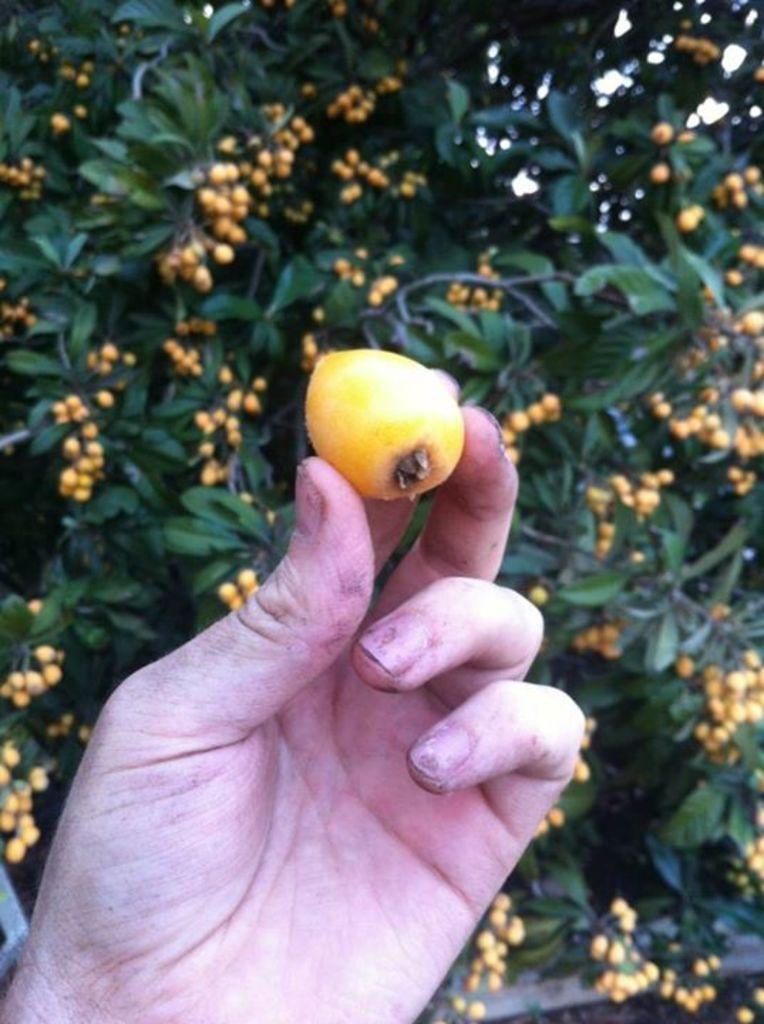Can you describe this image briefly? In this image we can see a person´s hand holding an object and there are few trees with fruits in the background. 